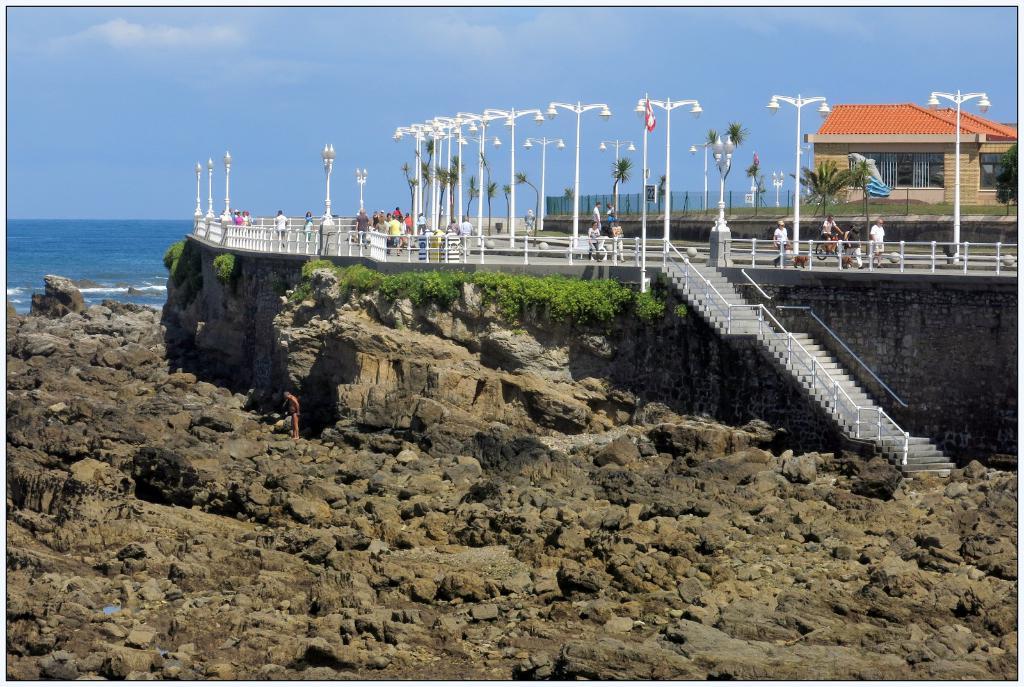Can you describe this image briefly? In this picture we can see stones, steps, light poles, water, plants, trees, fences, house and a group of people and some objects and in the background we can see the sky. 